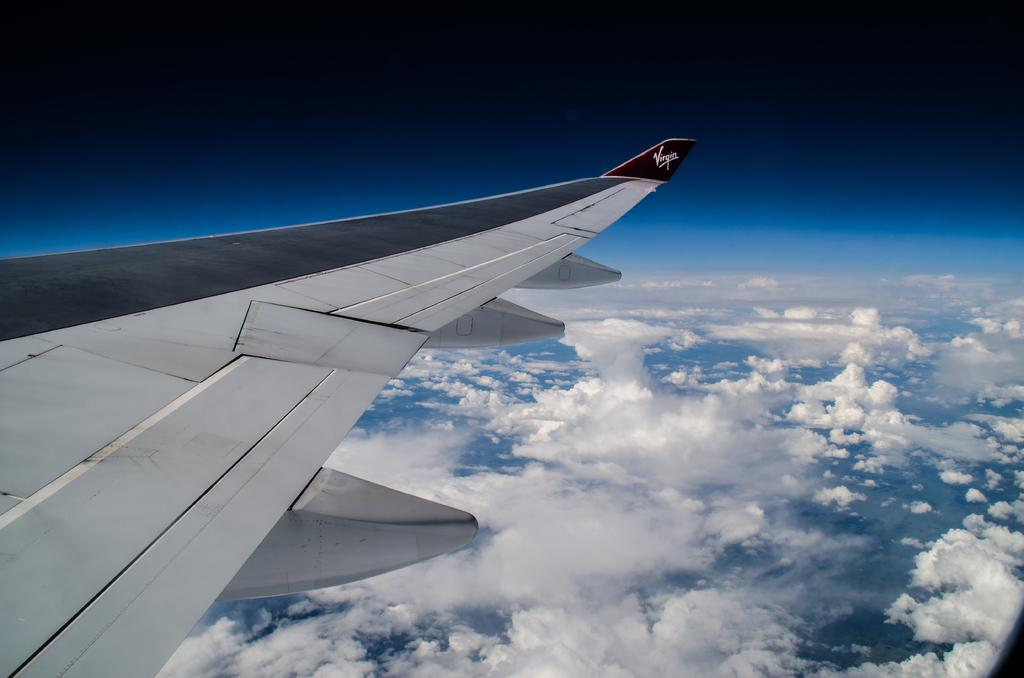What is the main subject of the image? The main subject of the image is an aircraft wing. Where is the aircraft wing located in the image? The aircraft wing is on the left side of the image. What can be seen in the background of the image? There is sky visible in the image. On which side of the image is the sky located? The sky is on the right side of the image. What type of mind control device can be seen in the image? There is no mind control device present in the image; it features an aircraft wing and sky. How does the beginner learn to fly the aircraft in the image? The image does not show anyone learning to fly an aircraft or provide information about the pilot's experience level. 